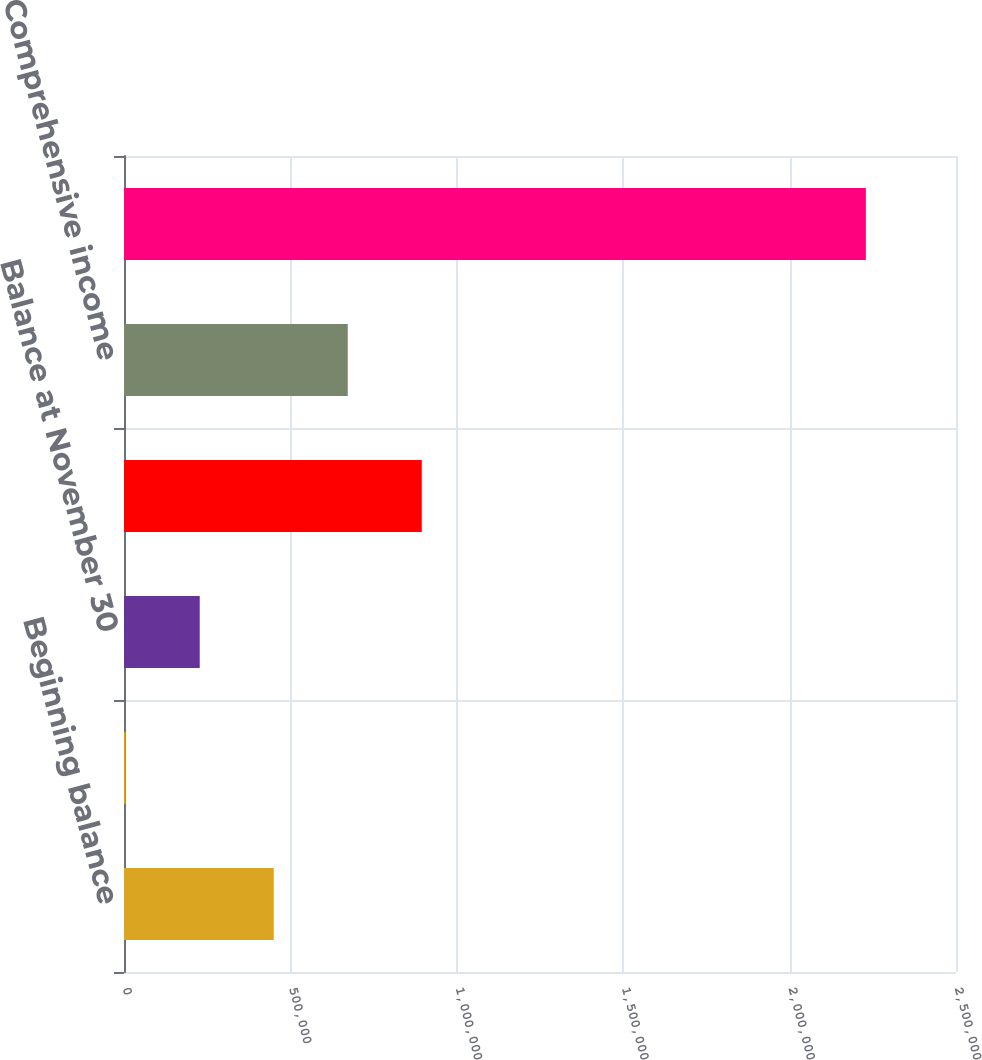<chart> <loc_0><loc_0><loc_500><loc_500><bar_chart><fcel>Beginning balance<fcel>Change in fair value of<fcel>Balance at November 30<fcel>Net earnings<fcel>Comprehensive income<fcel>Total stockholders' equity<nl><fcel>449952<fcel>5151<fcel>227552<fcel>894753<fcel>672353<fcel>2.22916e+06<nl></chart> 